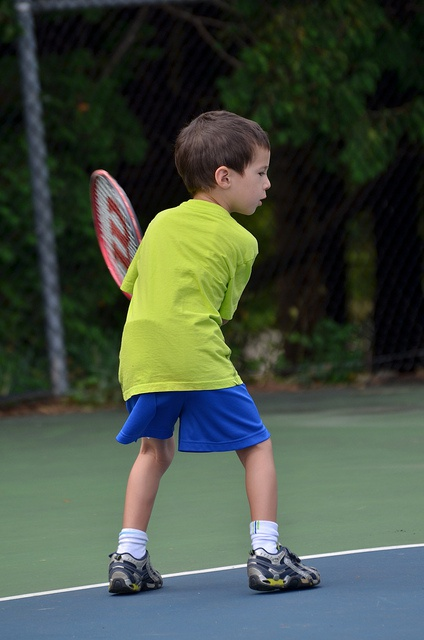Describe the objects in this image and their specific colors. I can see people in black, olive, khaki, and gray tones and tennis racket in black, darkgray, brown, maroon, and gray tones in this image. 